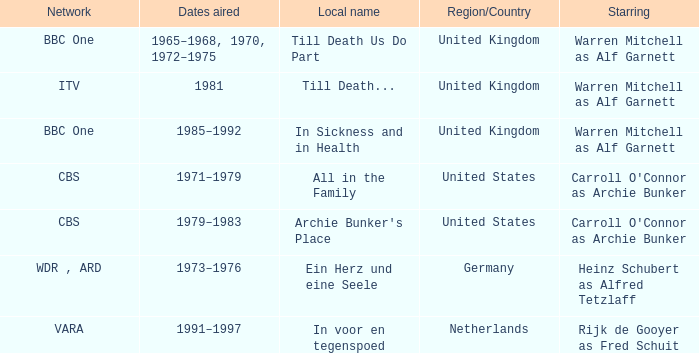What is the local name for the episodes that aired in 1981? Till Death... 